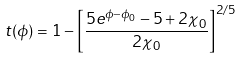<formula> <loc_0><loc_0><loc_500><loc_500>t ( \phi ) = 1 - \left [ \frac { 5 e ^ { \phi - \phi _ { 0 } } - 5 + 2 \chi _ { 0 } } { 2 \chi _ { 0 } } \right ] ^ { 2 / 5 }</formula> 